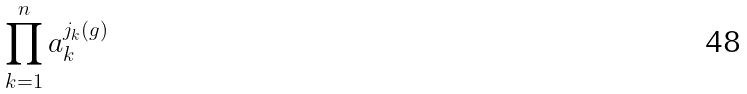Convert formula to latex. <formula><loc_0><loc_0><loc_500><loc_500>\prod _ { k = 1 } ^ { n } a _ { k } ^ { j _ { k } ( g ) }</formula> 